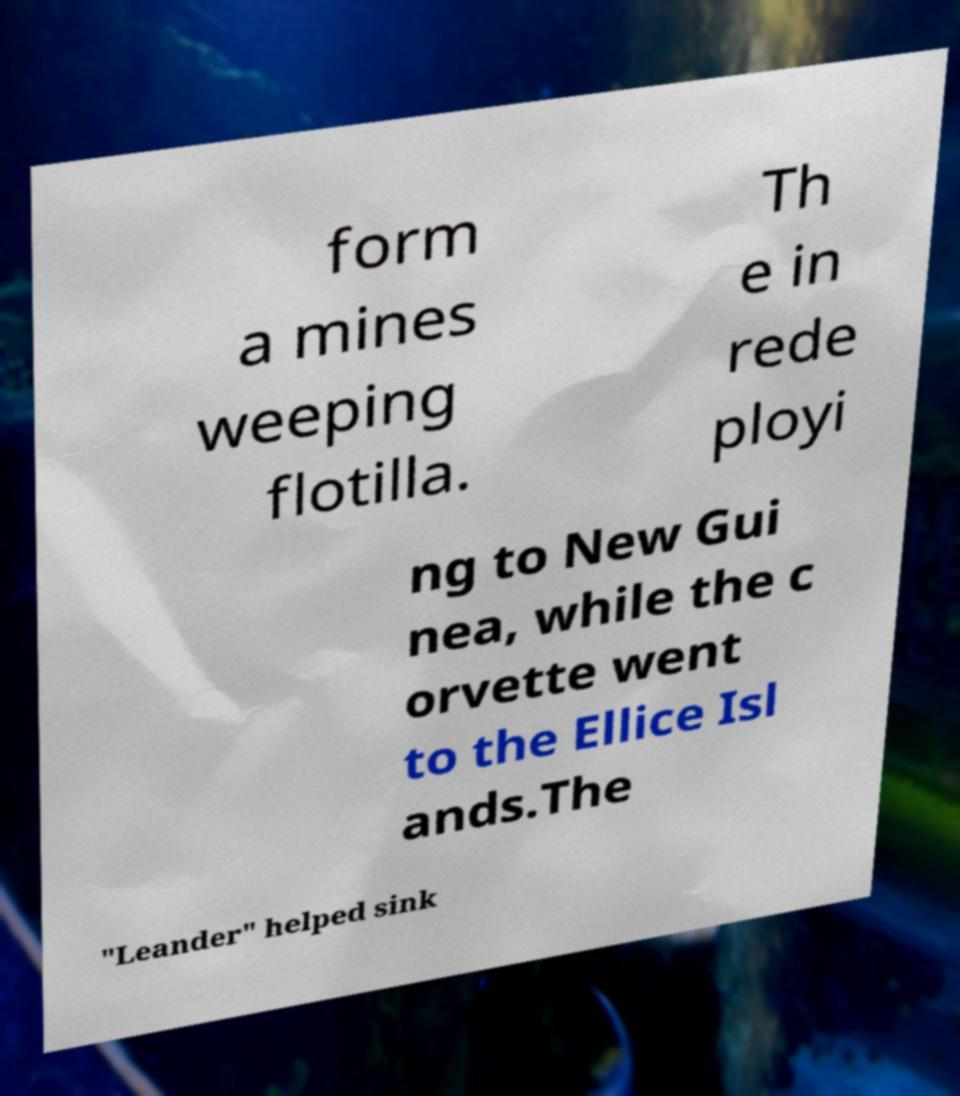For documentation purposes, I need the text within this image transcribed. Could you provide that? form a mines weeping flotilla. Th e in rede ployi ng to New Gui nea, while the c orvette went to the Ellice Isl ands.The "Leander" helped sink 